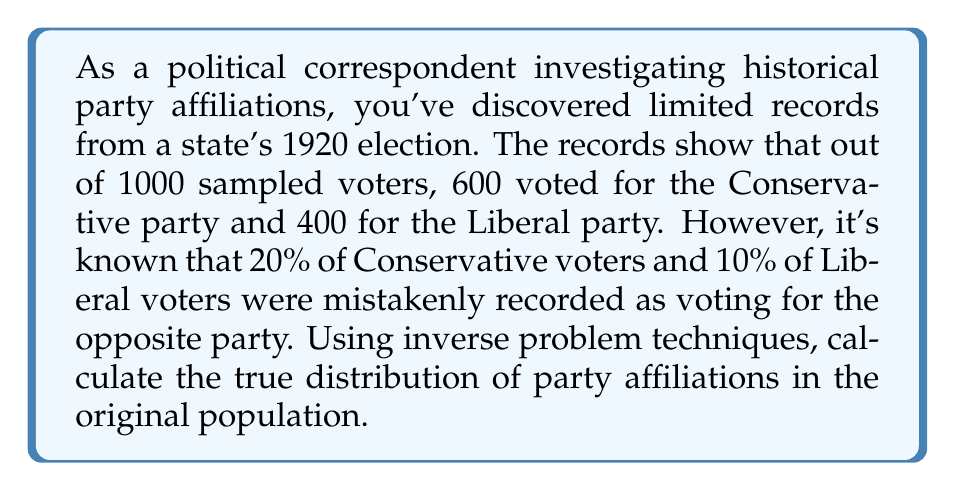Could you help me with this problem? Let's approach this step-by-step using inverse problem techniques:

1) Let $x$ be the true number of Conservative voters and $y$ be the true number of Liberal voters in the sample of 1000.

2) We can set up a system of equations based on the observed data and known error rates:

   $$0.8x + 0.1y = 600$$
   $$0.2x + 0.9y = 400$$

3) This is a linear system that can be represented in matrix form:

   $$\begin{bmatrix} 0.8 & 0.1 \\ 0.2 & 0.9 \end{bmatrix} \begin{bmatrix} x \\ y \end{bmatrix} = \begin{bmatrix} 600 \\ 400 \end{bmatrix}$$

4) To solve this, we can use the inverse matrix method:

   $$\begin{bmatrix} x \\ y \end{bmatrix} = \begin{bmatrix} 0.8 & 0.1 \\ 0.2 & 0.9 \end{bmatrix}^{-1} \begin{bmatrix} 600 \\ 400 \end{bmatrix}$$

5) The inverse of the matrix is:

   $$\begin{bmatrix} 0.8 & 0.1 \\ 0.2 & 0.9 \end{bmatrix}^{-1} = \frac{1}{0.8 * 0.9 - 0.1 * 0.2} \begin{bmatrix} 0.9 & -0.1 \\ -0.2 & 0.8 \end{bmatrix} = \begin{bmatrix} 1.2857 & -0.1429 \\ -0.2857 & 1.1429 \end{bmatrix}$$

6) Multiplying this by the observed results:

   $$\begin{bmatrix} x \\ y \end{bmatrix} = \begin{bmatrix} 1.2857 & -0.1429 \\ -0.2857 & 1.1429 \end{bmatrix} \begin{bmatrix} 600 \\ 400 \end{bmatrix} = \begin{bmatrix} 685.71 \\ 314.29 \end{bmatrix}$$

7) Rounding to the nearest whole number:

   $x = 686$ (Conservative voters)
   $y = 314$ (Liberal voters)

8) To get the distribution as percentages:

   Conservative: $\frac{686}{1000} * 100\% = 68.6\%$
   Liberal: $\frac{314}{1000} * 100\% = 31.4\%$
Answer: 68.6% Conservative, 31.4% Liberal 